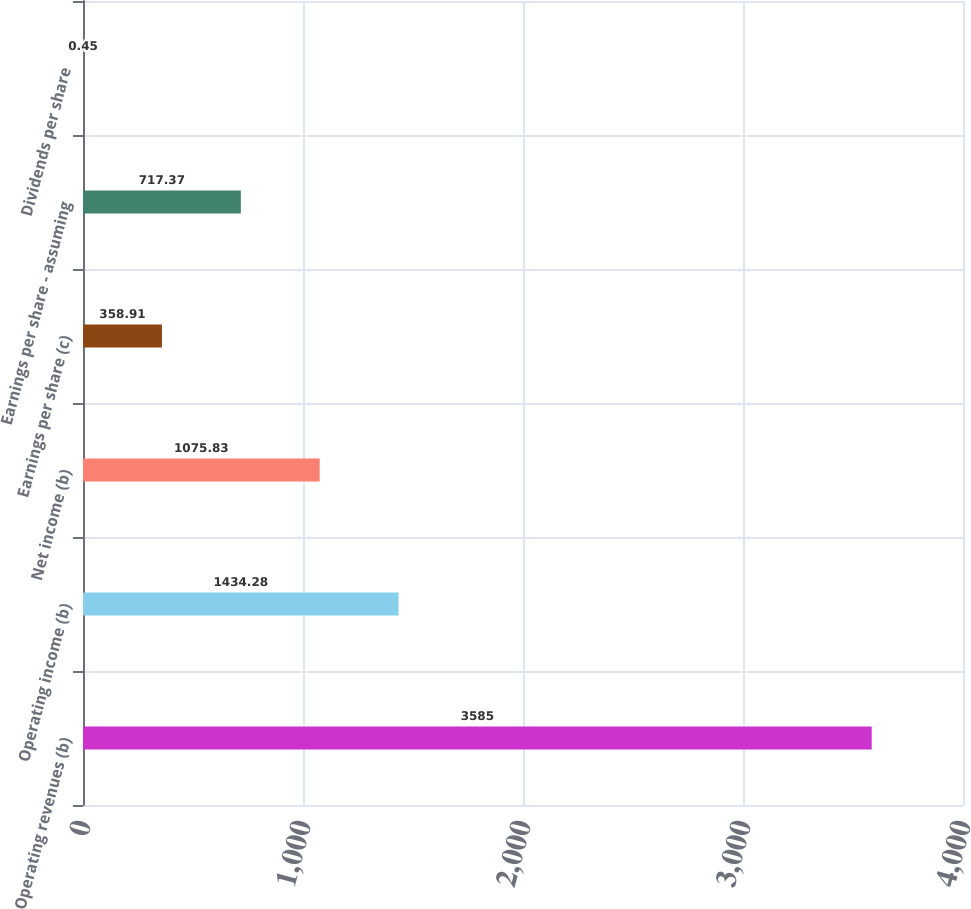Convert chart. <chart><loc_0><loc_0><loc_500><loc_500><bar_chart><fcel>Operating revenues (b)<fcel>Operating income (b)<fcel>Net income (b)<fcel>Earnings per share (c)<fcel>Earnings per share - assuming<fcel>Dividends per share<nl><fcel>3585<fcel>1434.28<fcel>1075.83<fcel>358.91<fcel>717.37<fcel>0.45<nl></chart> 